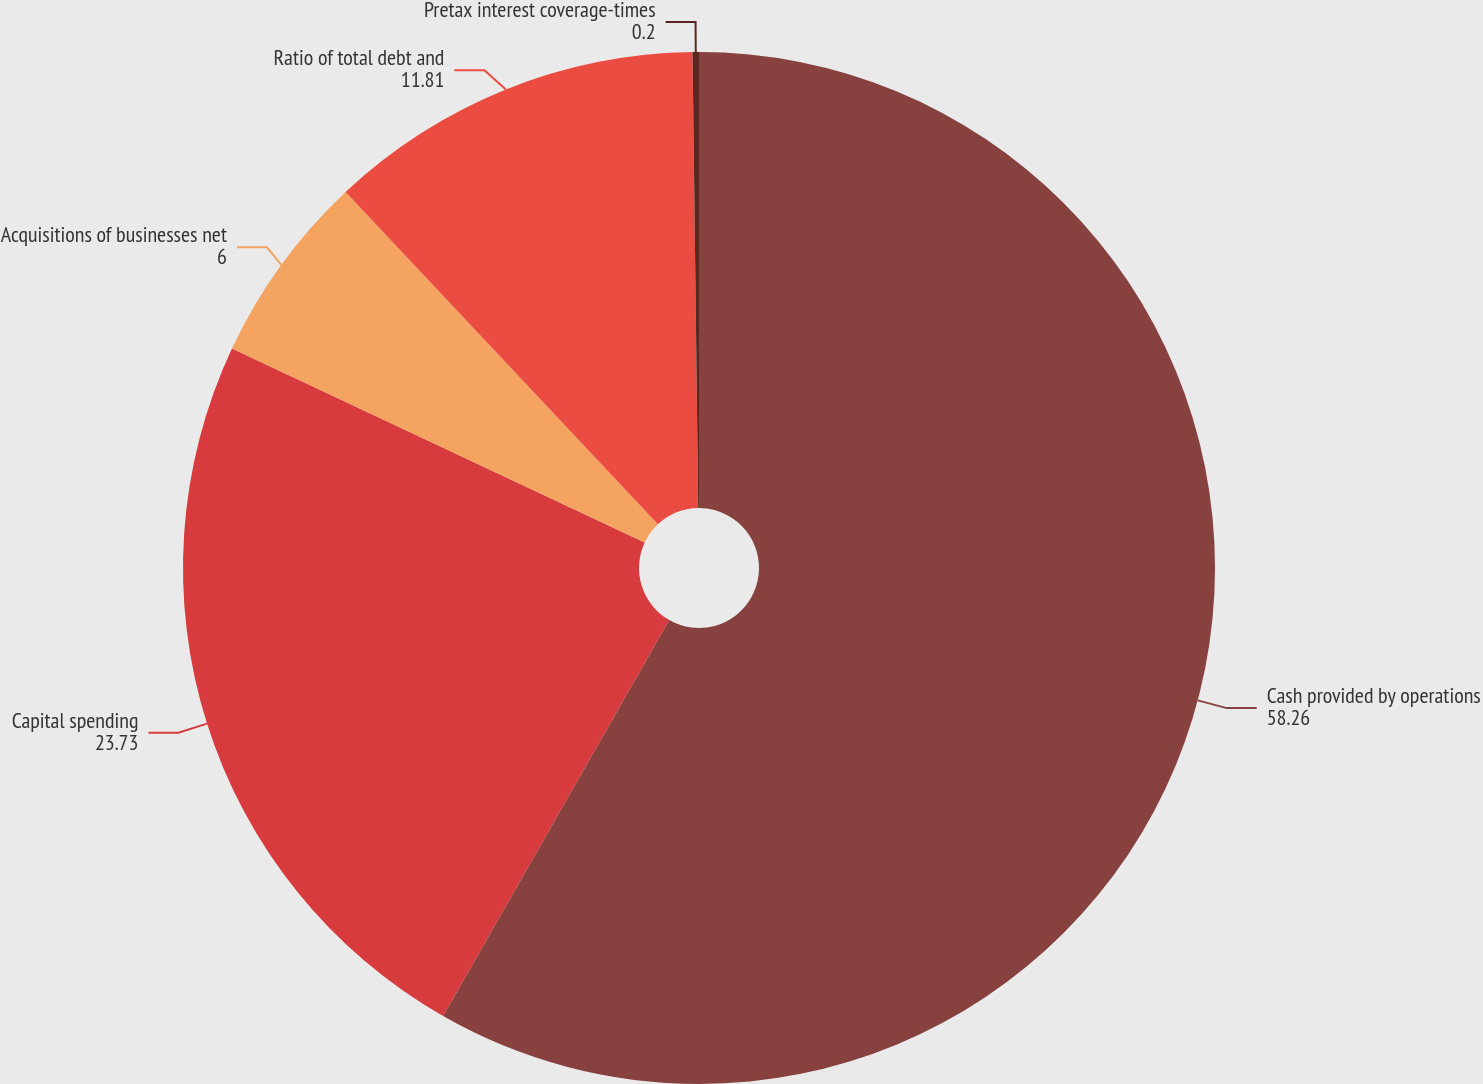Convert chart to OTSL. <chart><loc_0><loc_0><loc_500><loc_500><pie_chart><fcel>Cash provided by operations<fcel>Capital spending<fcel>Acquisitions of businesses net<fcel>Ratio of total debt and<fcel>Pretax interest coverage-times<nl><fcel>58.26%<fcel>23.73%<fcel>6.0%<fcel>11.81%<fcel>0.2%<nl></chart> 